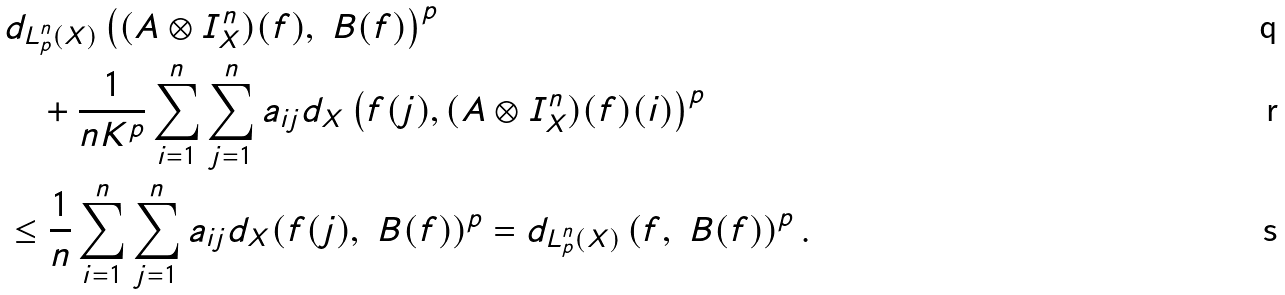<formula> <loc_0><loc_0><loc_500><loc_500>& d _ { L _ { p } ^ { n } ( X ) } \left ( ( A \otimes I _ { X } ^ { n } ) ( f ) , \ B ( f ) \right ) ^ { p } \\ & \quad + \frac { 1 } { n K ^ { p } } \sum _ { i = 1 } ^ { n } \sum _ { j = 1 } ^ { n } a _ { i j } d _ { X } \left ( f ( j ) , ( A \otimes I _ { X } ^ { n } ) ( f ) ( i ) \right ) ^ { p } \\ & \leq \frac { 1 } { n } \sum _ { i = 1 } ^ { n } \sum _ { j = 1 } ^ { n } a _ { i j } d _ { X } ( f ( j ) , \ B ( f ) ) ^ { p } = d _ { L _ { p } ^ { n } ( X ) } \left ( f , \ B ( f ) \right ) ^ { p } .</formula> 